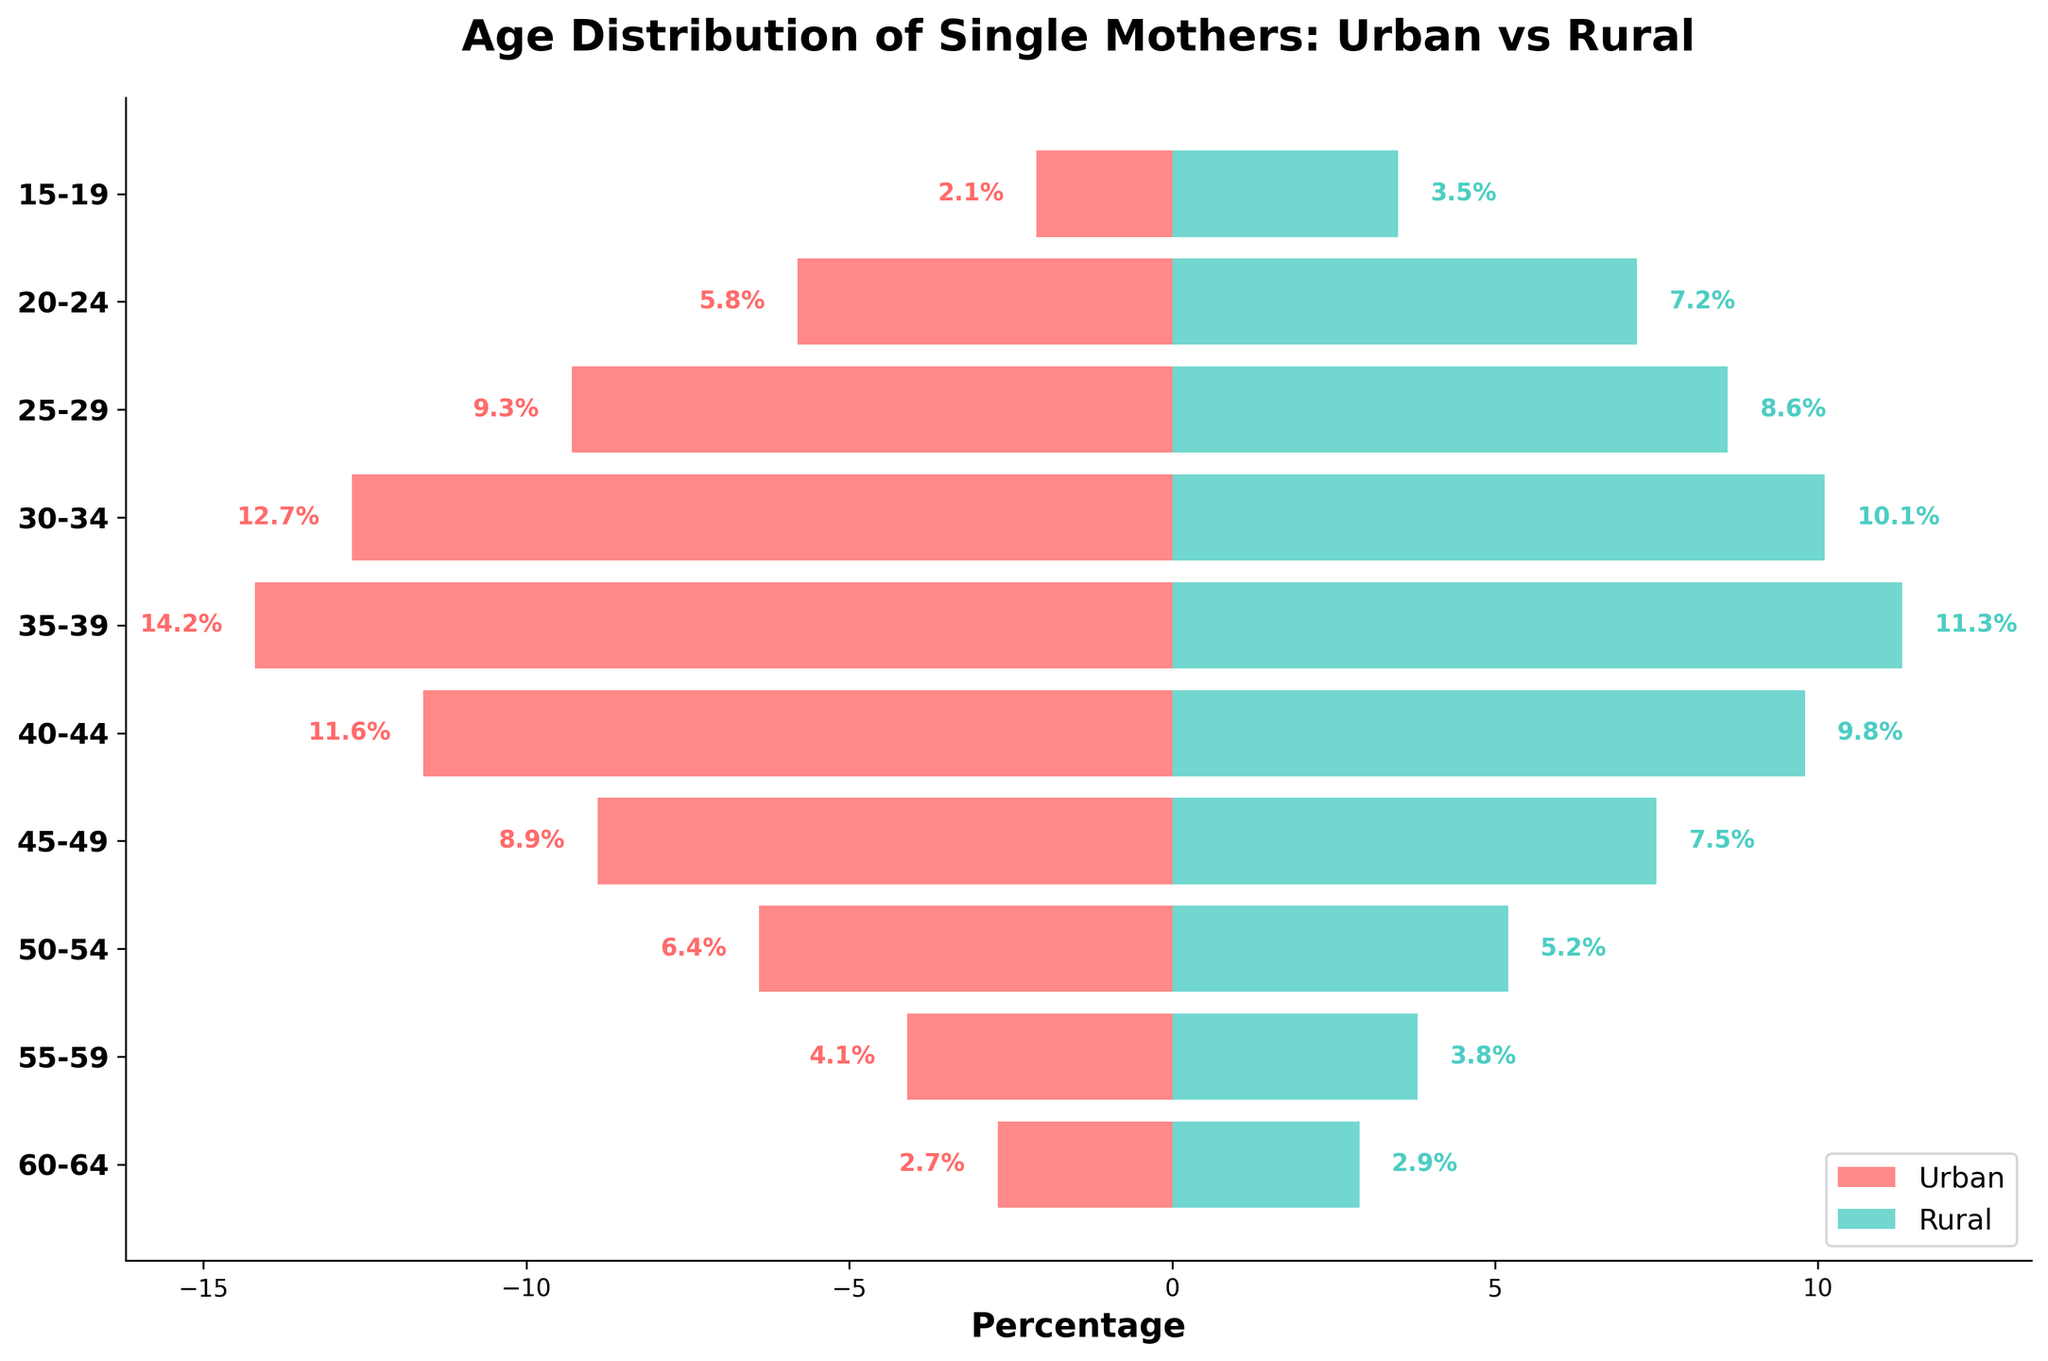What's the title of the figure? The title is typically displayed prominently at the top of the figure. By looking at this part of the figure, one can quickly understand what the visual is about.
Answer: Age Distribution of Single Mothers: Urban vs Rural How many age groups are displayed in the figure? The number of age groups can be determined by counting the bars or labels on the y-axis. Each group corresponds to an age range.
Answer: 10 Which age group has the highest percentage of urban single mothers? By examining the length of the red bars on the left side of the figure, one can identify which bar extends the farthest. This group's label corresponds to the answer.
Answer: 35-39 Are there any age groups where the percentage of rural single mothers is higher than urban single mothers? If so, which ones? Compare the lengths of the blue bars on the right side with the red bars on the left side for each age group. Identify any groups where the blue bar is longer.
Answer: 15-19, 20-24 What is the percentage difference of single mothers between urban and rural areas in the age group 30-34? Calculate the absolute difference between the percentages for urban and rural in this age group. Urban: 12.7%, Rural: 10.1%.
Answer: 2.6% Which age group has the smallest percentage of rural single mothers? Look for the shortest blue bar on the right side of the figure and note the corresponding age group.
Answer: 15-19 What is the combined percentage of urban and rural single mothers in the age group 50-54? Add the percentages of urban and rural single mothers within this age group. Urban: 6.4%, Rural: 5.2%.
Answer: 11.6% Which age group shows the closest percentage between urban and rural single mothers? Compare the red and blue bars for each age group to find the pair with the smallest difference.
Answer: 60-64 How does the percentage of single mothers aged 25-29 in rural areas compare to the same group in urban areas? Compare the lengths of the bars for the age group 25-29 on both sides. Urban: 9.3%, Rural: 8.6%.
Answer: Urban is higher by 0.7% What trend can be observed in the distribution of single mothers from urban to rural settings as age increases from 15 to 64? Observe the general trend of the lengths of the red and blue bars with increasing age. Typically, analyze if there is an increasing or decreasing pattern.
Answer: Urban percentages generally peak at 35-39 then decline; rural percentages peak at 30-34 then decline 